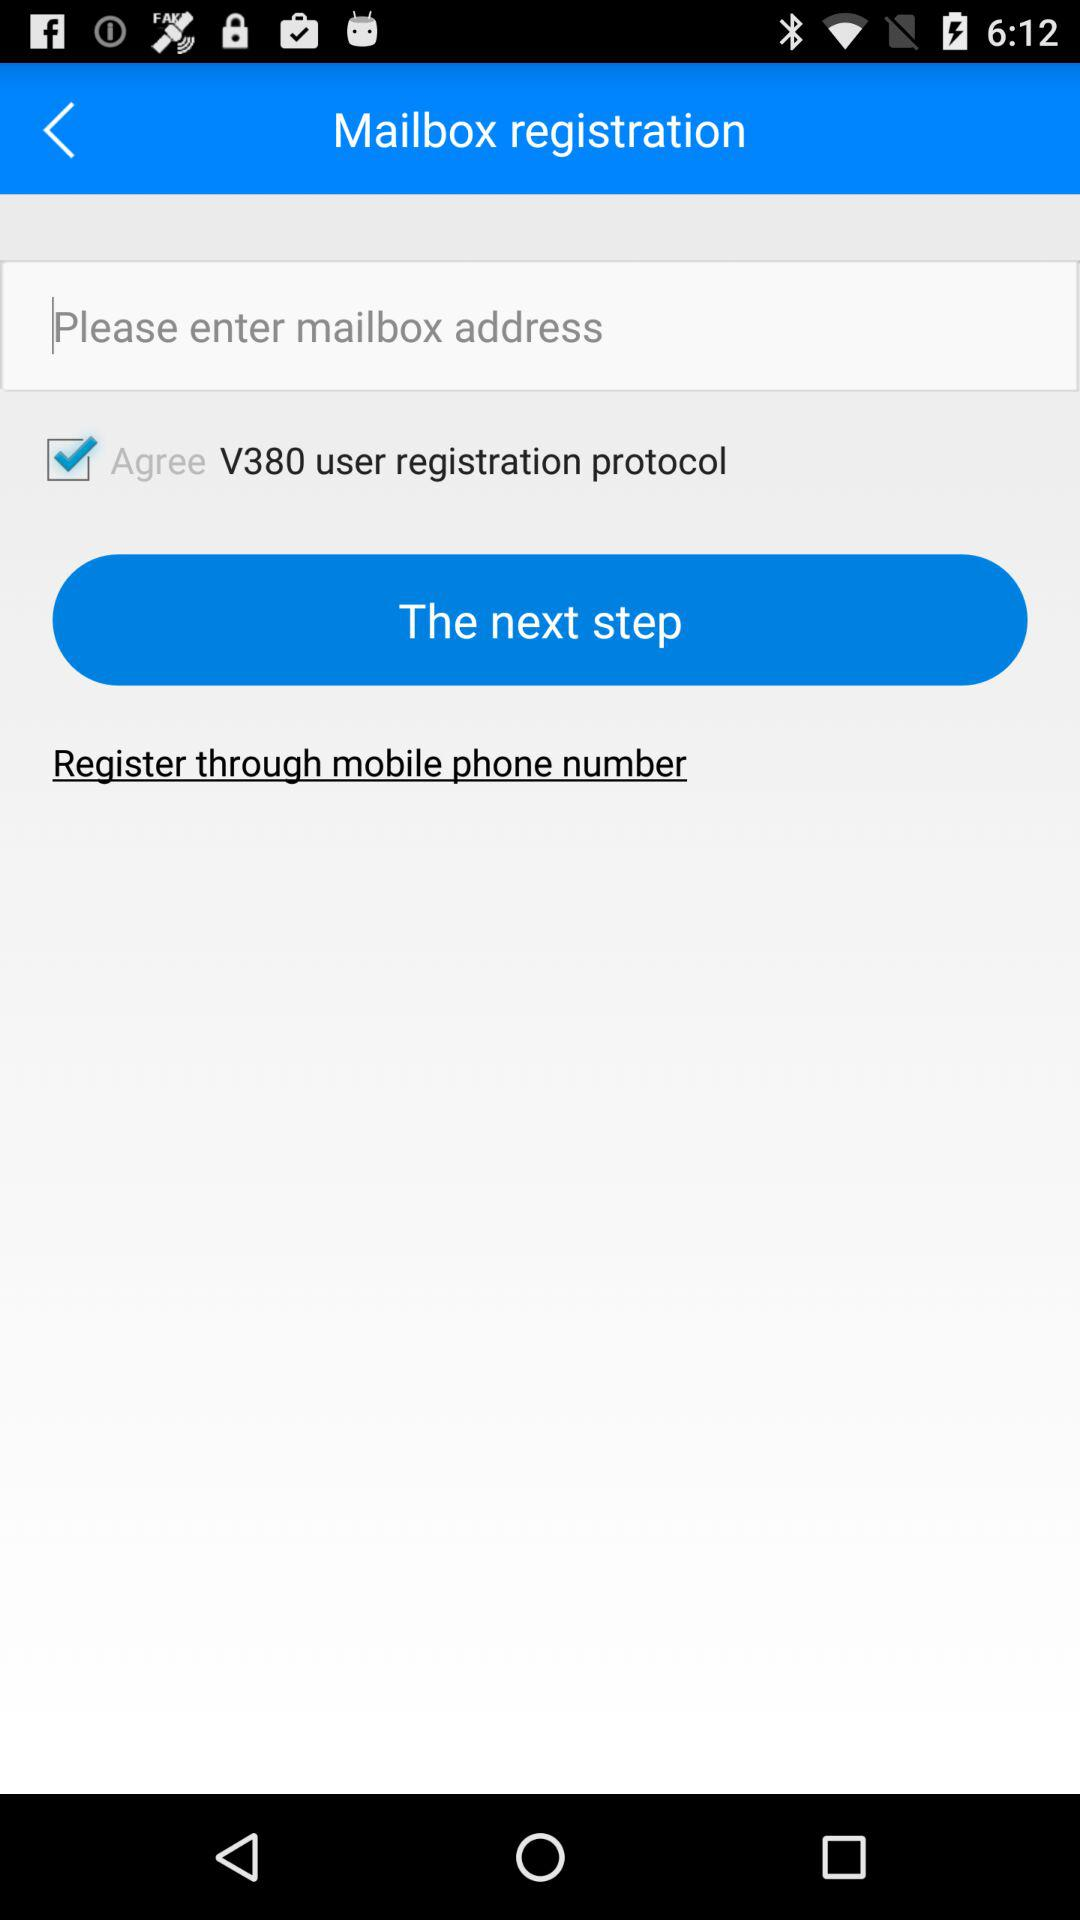What is the checked checkbox? The checked checkbox is "V380 user registration protocol". 